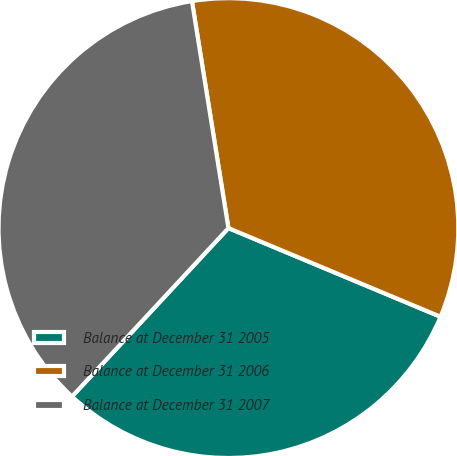<chart> <loc_0><loc_0><loc_500><loc_500><pie_chart><fcel>Balance at December 31 2005<fcel>Balance at December 31 2006<fcel>Balance at December 31 2007<nl><fcel>30.61%<fcel>33.84%<fcel>35.55%<nl></chart> 